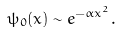<formula> <loc_0><loc_0><loc_500><loc_500>\psi _ { 0 } ( x ) \sim e ^ { - \alpha x ^ { 2 } } .</formula> 